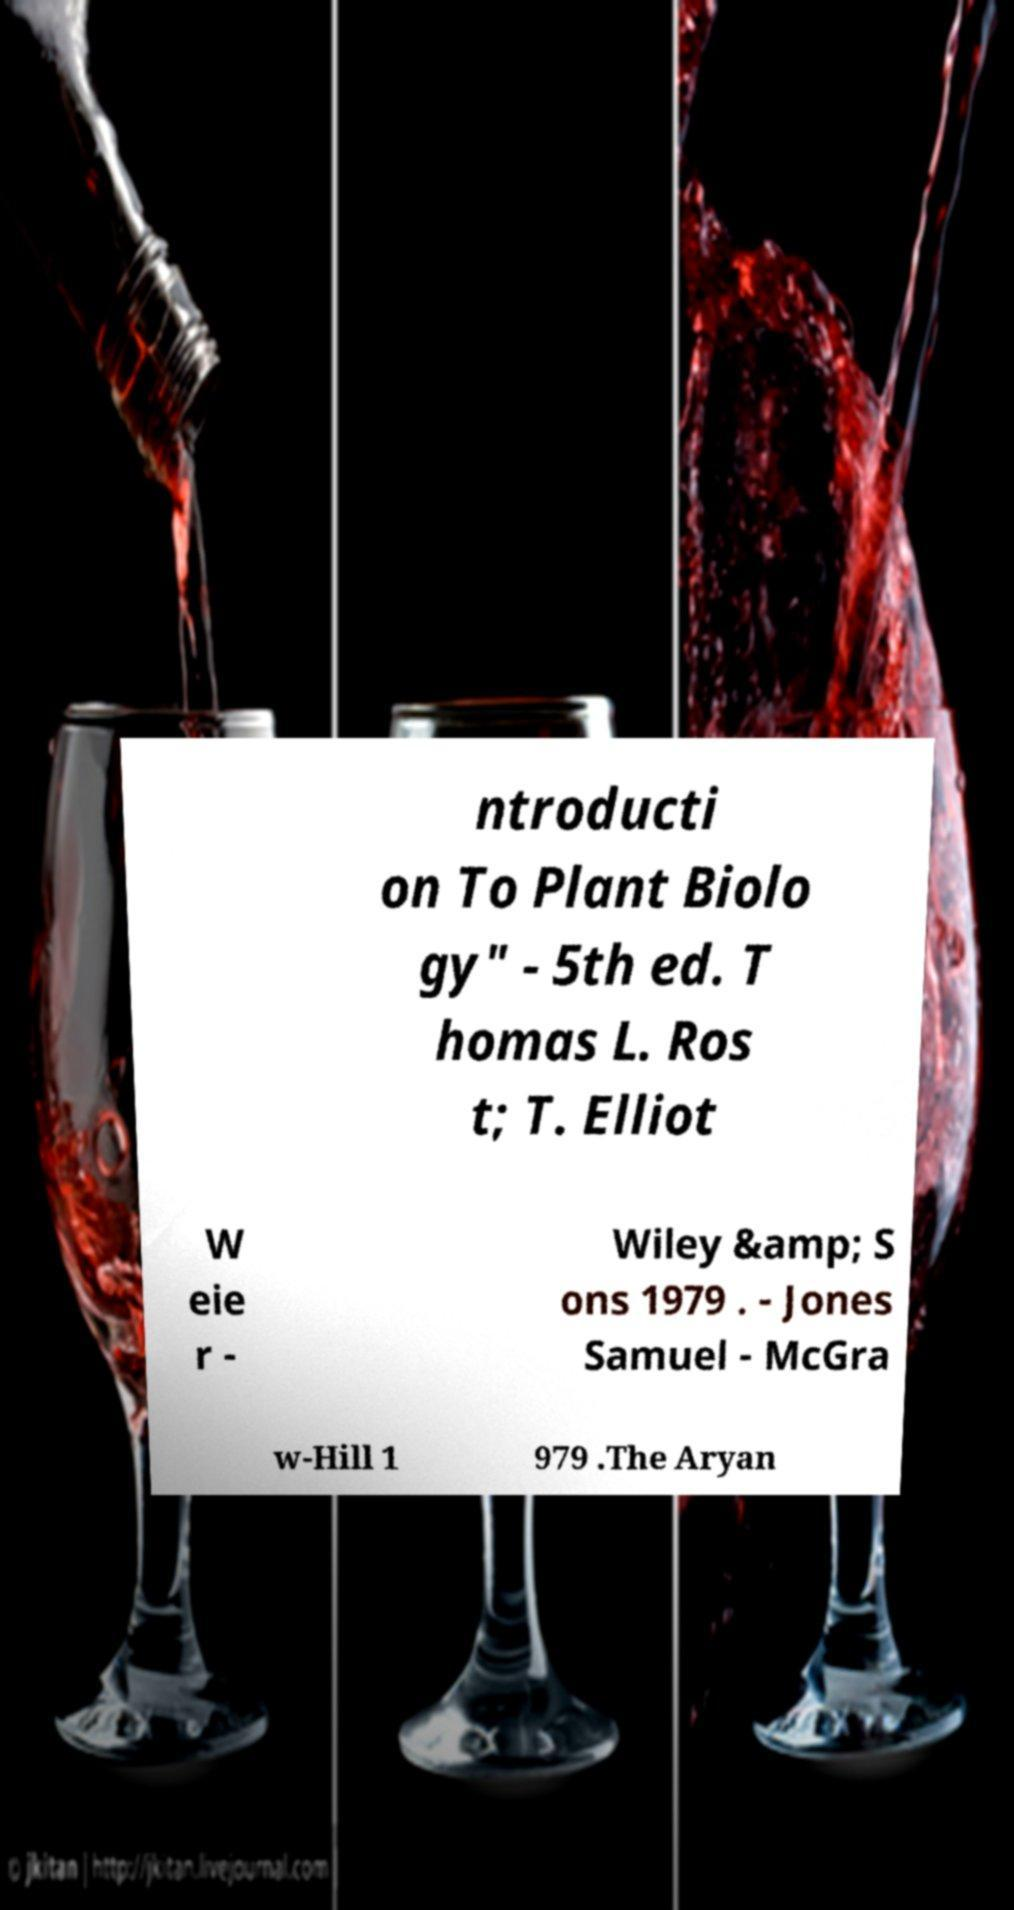Can you accurately transcribe the text from the provided image for me? ntroducti on To Plant Biolo gy" - 5th ed. T homas L. Ros t; T. Elliot W eie r - Wiley &amp; S ons 1979 . - Jones Samuel - McGra w-Hill 1 979 .The Aryan 